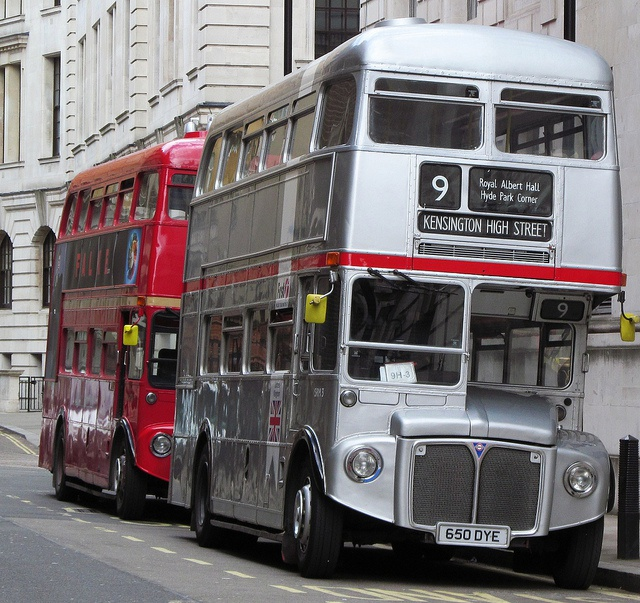Describe the objects in this image and their specific colors. I can see bus in lightgray, black, gray, and darkgray tones and bus in lightgray, black, gray, maroon, and brown tones in this image. 